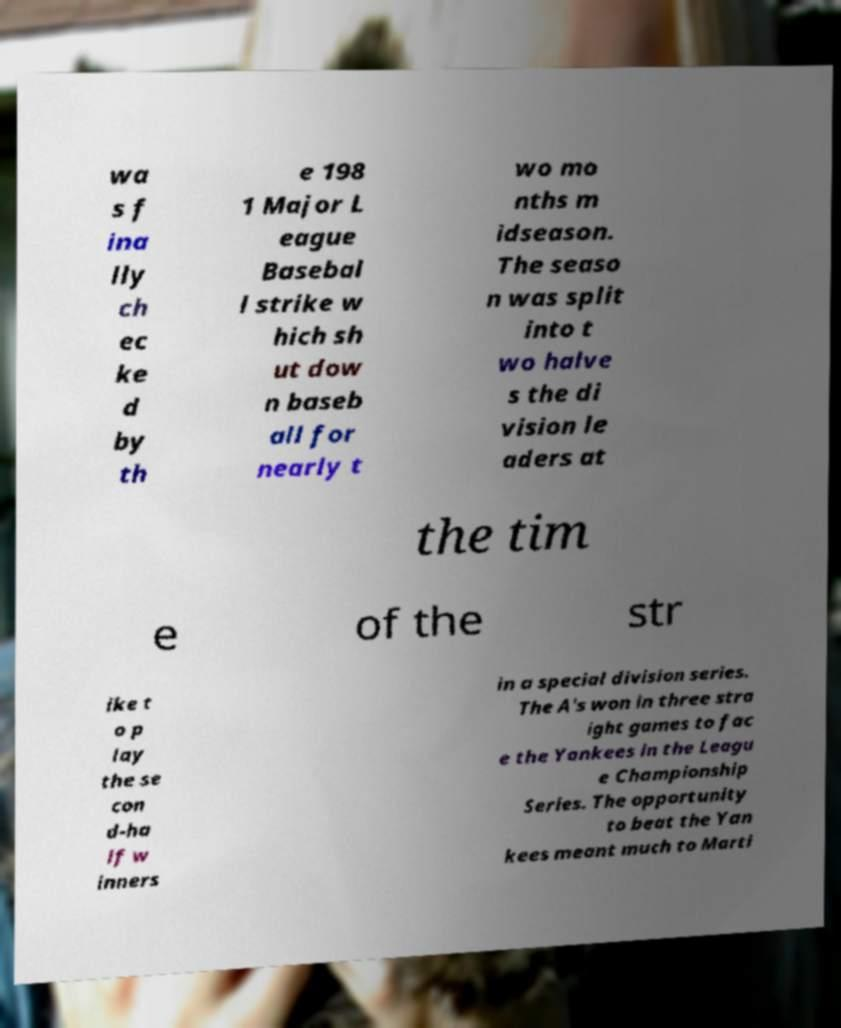Could you extract and type out the text from this image? wa s f ina lly ch ec ke d by th e 198 1 Major L eague Basebal l strike w hich sh ut dow n baseb all for nearly t wo mo nths m idseason. The seaso n was split into t wo halve s the di vision le aders at the tim e of the str ike t o p lay the se con d-ha lf w inners in a special division series. The A's won in three stra ight games to fac e the Yankees in the Leagu e Championship Series. The opportunity to beat the Yan kees meant much to Marti 